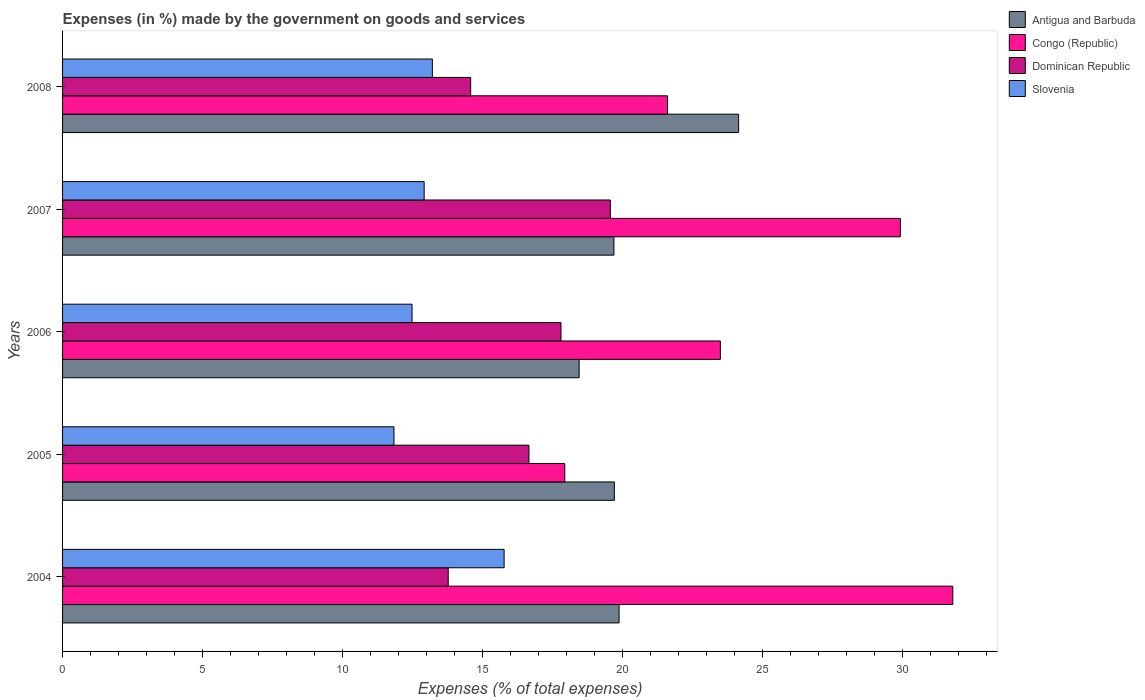How many different coloured bars are there?
Keep it short and to the point. 4. How many bars are there on the 2nd tick from the bottom?
Provide a short and direct response. 4. In how many cases, is the number of bars for a given year not equal to the number of legend labels?
Make the answer very short. 0. What is the percentage of expenses made by the government on goods and services in Antigua and Barbuda in 2004?
Your answer should be compact. 19.87. Across all years, what is the maximum percentage of expenses made by the government on goods and services in Dominican Republic?
Offer a very short reply. 19.56. Across all years, what is the minimum percentage of expenses made by the government on goods and services in Antigua and Barbuda?
Keep it short and to the point. 18.45. In which year was the percentage of expenses made by the government on goods and services in Dominican Republic maximum?
Your response must be concise. 2007. What is the total percentage of expenses made by the government on goods and services in Slovenia in the graph?
Your answer should be very brief. 66.2. What is the difference between the percentage of expenses made by the government on goods and services in Dominican Republic in 2006 and that in 2008?
Your answer should be compact. 3.23. What is the difference between the percentage of expenses made by the government on goods and services in Congo (Republic) in 2005 and the percentage of expenses made by the government on goods and services in Slovenia in 2007?
Offer a terse response. 5.02. What is the average percentage of expenses made by the government on goods and services in Congo (Republic) per year?
Make the answer very short. 24.95. In the year 2006, what is the difference between the percentage of expenses made by the government on goods and services in Congo (Republic) and percentage of expenses made by the government on goods and services in Antigua and Barbuda?
Your answer should be compact. 5.04. What is the ratio of the percentage of expenses made by the government on goods and services in Slovenia in 2005 to that in 2006?
Your answer should be compact. 0.95. What is the difference between the highest and the second highest percentage of expenses made by the government on goods and services in Dominican Republic?
Make the answer very short. 1.76. What is the difference between the highest and the lowest percentage of expenses made by the government on goods and services in Slovenia?
Your answer should be very brief. 3.93. In how many years, is the percentage of expenses made by the government on goods and services in Congo (Republic) greater than the average percentage of expenses made by the government on goods and services in Congo (Republic) taken over all years?
Keep it short and to the point. 2. What does the 3rd bar from the top in 2007 represents?
Make the answer very short. Congo (Republic). What does the 4th bar from the bottom in 2007 represents?
Offer a terse response. Slovenia. Is it the case that in every year, the sum of the percentage of expenses made by the government on goods and services in Congo (Republic) and percentage of expenses made by the government on goods and services in Slovenia is greater than the percentage of expenses made by the government on goods and services in Antigua and Barbuda?
Ensure brevity in your answer.  Yes. How many bars are there?
Keep it short and to the point. 20. Are all the bars in the graph horizontal?
Your answer should be compact. Yes. How many years are there in the graph?
Give a very brief answer. 5. What is the difference between two consecutive major ticks on the X-axis?
Ensure brevity in your answer.  5. Does the graph contain grids?
Ensure brevity in your answer.  No. Where does the legend appear in the graph?
Give a very brief answer. Top right. How are the legend labels stacked?
Offer a very short reply. Vertical. What is the title of the graph?
Ensure brevity in your answer.  Expenses (in %) made by the government on goods and services. Does "Middle East & North Africa (all income levels)" appear as one of the legend labels in the graph?
Your response must be concise. No. What is the label or title of the X-axis?
Keep it short and to the point. Expenses (% of total expenses). What is the Expenses (% of total expenses) of Antigua and Barbuda in 2004?
Your response must be concise. 19.87. What is the Expenses (% of total expenses) of Congo (Republic) in 2004?
Provide a short and direct response. 31.79. What is the Expenses (% of total expenses) of Dominican Republic in 2004?
Offer a terse response. 13.77. What is the Expenses (% of total expenses) in Slovenia in 2004?
Provide a short and direct response. 15.77. What is the Expenses (% of total expenses) of Antigua and Barbuda in 2005?
Provide a short and direct response. 19.71. What is the Expenses (% of total expenses) of Congo (Republic) in 2005?
Make the answer very short. 17.93. What is the Expenses (% of total expenses) in Dominican Republic in 2005?
Provide a succinct answer. 16.65. What is the Expenses (% of total expenses) in Slovenia in 2005?
Your answer should be very brief. 11.83. What is the Expenses (% of total expenses) of Antigua and Barbuda in 2006?
Ensure brevity in your answer.  18.45. What is the Expenses (% of total expenses) in Congo (Republic) in 2006?
Make the answer very short. 23.49. What is the Expenses (% of total expenses) in Dominican Republic in 2006?
Provide a succinct answer. 17.8. What is the Expenses (% of total expenses) of Slovenia in 2006?
Your answer should be very brief. 12.48. What is the Expenses (% of total expenses) in Antigua and Barbuda in 2007?
Give a very brief answer. 19.69. What is the Expenses (% of total expenses) in Congo (Republic) in 2007?
Ensure brevity in your answer.  29.92. What is the Expenses (% of total expenses) in Dominican Republic in 2007?
Offer a very short reply. 19.56. What is the Expenses (% of total expenses) in Slovenia in 2007?
Your answer should be very brief. 12.91. What is the Expenses (% of total expenses) in Antigua and Barbuda in 2008?
Your response must be concise. 24.14. What is the Expenses (% of total expenses) of Congo (Republic) in 2008?
Give a very brief answer. 21.6. What is the Expenses (% of total expenses) of Dominican Republic in 2008?
Offer a very short reply. 14.57. What is the Expenses (% of total expenses) in Slovenia in 2008?
Provide a short and direct response. 13.21. Across all years, what is the maximum Expenses (% of total expenses) in Antigua and Barbuda?
Keep it short and to the point. 24.14. Across all years, what is the maximum Expenses (% of total expenses) in Congo (Republic)?
Ensure brevity in your answer.  31.79. Across all years, what is the maximum Expenses (% of total expenses) in Dominican Republic?
Offer a very short reply. 19.56. Across all years, what is the maximum Expenses (% of total expenses) in Slovenia?
Your response must be concise. 15.77. Across all years, what is the minimum Expenses (% of total expenses) of Antigua and Barbuda?
Offer a very short reply. 18.45. Across all years, what is the minimum Expenses (% of total expenses) of Congo (Republic)?
Your answer should be very brief. 17.93. Across all years, what is the minimum Expenses (% of total expenses) of Dominican Republic?
Offer a very short reply. 13.77. Across all years, what is the minimum Expenses (% of total expenses) of Slovenia?
Your answer should be compact. 11.83. What is the total Expenses (% of total expenses) of Antigua and Barbuda in the graph?
Offer a terse response. 101.86. What is the total Expenses (% of total expenses) in Congo (Republic) in the graph?
Provide a succinct answer. 124.73. What is the total Expenses (% of total expenses) of Dominican Republic in the graph?
Your answer should be compact. 82.36. What is the total Expenses (% of total expenses) in Slovenia in the graph?
Ensure brevity in your answer.  66.2. What is the difference between the Expenses (% of total expenses) in Antigua and Barbuda in 2004 and that in 2005?
Give a very brief answer. 0.17. What is the difference between the Expenses (% of total expenses) in Congo (Republic) in 2004 and that in 2005?
Your answer should be compact. 13.86. What is the difference between the Expenses (% of total expenses) of Dominican Republic in 2004 and that in 2005?
Keep it short and to the point. -2.88. What is the difference between the Expenses (% of total expenses) in Slovenia in 2004 and that in 2005?
Your answer should be very brief. 3.93. What is the difference between the Expenses (% of total expenses) of Antigua and Barbuda in 2004 and that in 2006?
Keep it short and to the point. 1.43. What is the difference between the Expenses (% of total expenses) in Congo (Republic) in 2004 and that in 2006?
Offer a terse response. 8.3. What is the difference between the Expenses (% of total expenses) in Dominican Republic in 2004 and that in 2006?
Provide a short and direct response. -4.03. What is the difference between the Expenses (% of total expenses) in Slovenia in 2004 and that in 2006?
Give a very brief answer. 3.29. What is the difference between the Expenses (% of total expenses) in Antigua and Barbuda in 2004 and that in 2007?
Ensure brevity in your answer.  0.18. What is the difference between the Expenses (% of total expenses) of Congo (Republic) in 2004 and that in 2007?
Offer a very short reply. 1.87. What is the difference between the Expenses (% of total expenses) of Dominican Republic in 2004 and that in 2007?
Make the answer very short. -5.79. What is the difference between the Expenses (% of total expenses) of Slovenia in 2004 and that in 2007?
Ensure brevity in your answer.  2.86. What is the difference between the Expenses (% of total expenses) of Antigua and Barbuda in 2004 and that in 2008?
Provide a succinct answer. -4.27. What is the difference between the Expenses (% of total expenses) of Congo (Republic) in 2004 and that in 2008?
Keep it short and to the point. 10.19. What is the difference between the Expenses (% of total expenses) of Dominican Republic in 2004 and that in 2008?
Your response must be concise. -0.8. What is the difference between the Expenses (% of total expenses) in Slovenia in 2004 and that in 2008?
Give a very brief answer. 2.56. What is the difference between the Expenses (% of total expenses) of Antigua and Barbuda in 2005 and that in 2006?
Your response must be concise. 1.26. What is the difference between the Expenses (% of total expenses) in Congo (Republic) in 2005 and that in 2006?
Your answer should be compact. -5.56. What is the difference between the Expenses (% of total expenses) in Dominican Republic in 2005 and that in 2006?
Give a very brief answer. -1.14. What is the difference between the Expenses (% of total expenses) of Slovenia in 2005 and that in 2006?
Provide a succinct answer. -0.65. What is the difference between the Expenses (% of total expenses) in Antigua and Barbuda in 2005 and that in 2007?
Offer a very short reply. 0.01. What is the difference between the Expenses (% of total expenses) of Congo (Republic) in 2005 and that in 2007?
Give a very brief answer. -11.98. What is the difference between the Expenses (% of total expenses) in Dominican Republic in 2005 and that in 2007?
Give a very brief answer. -2.91. What is the difference between the Expenses (% of total expenses) of Slovenia in 2005 and that in 2007?
Your answer should be very brief. -1.08. What is the difference between the Expenses (% of total expenses) in Antigua and Barbuda in 2005 and that in 2008?
Offer a terse response. -4.44. What is the difference between the Expenses (% of total expenses) in Congo (Republic) in 2005 and that in 2008?
Provide a succinct answer. -3.67. What is the difference between the Expenses (% of total expenses) in Dominican Republic in 2005 and that in 2008?
Offer a terse response. 2.08. What is the difference between the Expenses (% of total expenses) of Slovenia in 2005 and that in 2008?
Offer a very short reply. -1.37. What is the difference between the Expenses (% of total expenses) of Antigua and Barbuda in 2006 and that in 2007?
Offer a very short reply. -1.24. What is the difference between the Expenses (% of total expenses) of Congo (Republic) in 2006 and that in 2007?
Your answer should be compact. -6.43. What is the difference between the Expenses (% of total expenses) in Dominican Republic in 2006 and that in 2007?
Offer a very short reply. -1.76. What is the difference between the Expenses (% of total expenses) of Slovenia in 2006 and that in 2007?
Your response must be concise. -0.43. What is the difference between the Expenses (% of total expenses) in Antigua and Barbuda in 2006 and that in 2008?
Offer a terse response. -5.69. What is the difference between the Expenses (% of total expenses) in Congo (Republic) in 2006 and that in 2008?
Your answer should be compact. 1.89. What is the difference between the Expenses (% of total expenses) in Dominican Republic in 2006 and that in 2008?
Your answer should be very brief. 3.23. What is the difference between the Expenses (% of total expenses) in Slovenia in 2006 and that in 2008?
Offer a terse response. -0.73. What is the difference between the Expenses (% of total expenses) of Antigua and Barbuda in 2007 and that in 2008?
Offer a terse response. -4.45. What is the difference between the Expenses (% of total expenses) in Congo (Republic) in 2007 and that in 2008?
Give a very brief answer. 8.32. What is the difference between the Expenses (% of total expenses) in Dominican Republic in 2007 and that in 2008?
Provide a succinct answer. 4.99. What is the difference between the Expenses (% of total expenses) in Slovenia in 2007 and that in 2008?
Offer a very short reply. -0.29. What is the difference between the Expenses (% of total expenses) of Antigua and Barbuda in 2004 and the Expenses (% of total expenses) of Congo (Republic) in 2005?
Offer a terse response. 1.94. What is the difference between the Expenses (% of total expenses) of Antigua and Barbuda in 2004 and the Expenses (% of total expenses) of Dominican Republic in 2005?
Your answer should be compact. 3.22. What is the difference between the Expenses (% of total expenses) of Antigua and Barbuda in 2004 and the Expenses (% of total expenses) of Slovenia in 2005?
Your answer should be very brief. 8.04. What is the difference between the Expenses (% of total expenses) of Congo (Republic) in 2004 and the Expenses (% of total expenses) of Dominican Republic in 2005?
Your answer should be very brief. 15.14. What is the difference between the Expenses (% of total expenses) of Congo (Republic) in 2004 and the Expenses (% of total expenses) of Slovenia in 2005?
Your answer should be very brief. 19.96. What is the difference between the Expenses (% of total expenses) in Dominican Republic in 2004 and the Expenses (% of total expenses) in Slovenia in 2005?
Provide a short and direct response. 1.94. What is the difference between the Expenses (% of total expenses) in Antigua and Barbuda in 2004 and the Expenses (% of total expenses) in Congo (Republic) in 2006?
Provide a short and direct response. -3.62. What is the difference between the Expenses (% of total expenses) of Antigua and Barbuda in 2004 and the Expenses (% of total expenses) of Dominican Republic in 2006?
Offer a very short reply. 2.07. What is the difference between the Expenses (% of total expenses) in Antigua and Barbuda in 2004 and the Expenses (% of total expenses) in Slovenia in 2006?
Keep it short and to the point. 7.39. What is the difference between the Expenses (% of total expenses) in Congo (Republic) in 2004 and the Expenses (% of total expenses) in Dominican Republic in 2006?
Make the answer very short. 13.99. What is the difference between the Expenses (% of total expenses) of Congo (Republic) in 2004 and the Expenses (% of total expenses) of Slovenia in 2006?
Make the answer very short. 19.31. What is the difference between the Expenses (% of total expenses) in Dominican Republic in 2004 and the Expenses (% of total expenses) in Slovenia in 2006?
Ensure brevity in your answer.  1.29. What is the difference between the Expenses (% of total expenses) of Antigua and Barbuda in 2004 and the Expenses (% of total expenses) of Congo (Republic) in 2007?
Offer a very short reply. -10.04. What is the difference between the Expenses (% of total expenses) of Antigua and Barbuda in 2004 and the Expenses (% of total expenses) of Dominican Republic in 2007?
Make the answer very short. 0.31. What is the difference between the Expenses (% of total expenses) in Antigua and Barbuda in 2004 and the Expenses (% of total expenses) in Slovenia in 2007?
Keep it short and to the point. 6.96. What is the difference between the Expenses (% of total expenses) in Congo (Republic) in 2004 and the Expenses (% of total expenses) in Dominican Republic in 2007?
Your response must be concise. 12.23. What is the difference between the Expenses (% of total expenses) in Congo (Republic) in 2004 and the Expenses (% of total expenses) in Slovenia in 2007?
Offer a terse response. 18.88. What is the difference between the Expenses (% of total expenses) in Dominican Republic in 2004 and the Expenses (% of total expenses) in Slovenia in 2007?
Provide a short and direct response. 0.86. What is the difference between the Expenses (% of total expenses) of Antigua and Barbuda in 2004 and the Expenses (% of total expenses) of Congo (Republic) in 2008?
Offer a terse response. -1.73. What is the difference between the Expenses (% of total expenses) in Antigua and Barbuda in 2004 and the Expenses (% of total expenses) in Dominican Republic in 2008?
Your answer should be very brief. 5.3. What is the difference between the Expenses (% of total expenses) of Antigua and Barbuda in 2004 and the Expenses (% of total expenses) of Slovenia in 2008?
Keep it short and to the point. 6.67. What is the difference between the Expenses (% of total expenses) of Congo (Republic) in 2004 and the Expenses (% of total expenses) of Dominican Republic in 2008?
Offer a very short reply. 17.22. What is the difference between the Expenses (% of total expenses) of Congo (Republic) in 2004 and the Expenses (% of total expenses) of Slovenia in 2008?
Offer a very short reply. 18.58. What is the difference between the Expenses (% of total expenses) of Dominican Republic in 2004 and the Expenses (% of total expenses) of Slovenia in 2008?
Your response must be concise. 0.57. What is the difference between the Expenses (% of total expenses) of Antigua and Barbuda in 2005 and the Expenses (% of total expenses) of Congo (Republic) in 2006?
Offer a terse response. -3.79. What is the difference between the Expenses (% of total expenses) in Antigua and Barbuda in 2005 and the Expenses (% of total expenses) in Dominican Republic in 2006?
Make the answer very short. 1.91. What is the difference between the Expenses (% of total expenses) of Antigua and Barbuda in 2005 and the Expenses (% of total expenses) of Slovenia in 2006?
Give a very brief answer. 7.23. What is the difference between the Expenses (% of total expenses) in Congo (Republic) in 2005 and the Expenses (% of total expenses) in Dominican Republic in 2006?
Offer a very short reply. 0.13. What is the difference between the Expenses (% of total expenses) in Congo (Republic) in 2005 and the Expenses (% of total expenses) in Slovenia in 2006?
Offer a very short reply. 5.45. What is the difference between the Expenses (% of total expenses) of Dominican Republic in 2005 and the Expenses (% of total expenses) of Slovenia in 2006?
Your response must be concise. 4.17. What is the difference between the Expenses (% of total expenses) of Antigua and Barbuda in 2005 and the Expenses (% of total expenses) of Congo (Republic) in 2007?
Your response must be concise. -10.21. What is the difference between the Expenses (% of total expenses) of Antigua and Barbuda in 2005 and the Expenses (% of total expenses) of Dominican Republic in 2007?
Ensure brevity in your answer.  0.14. What is the difference between the Expenses (% of total expenses) in Antigua and Barbuda in 2005 and the Expenses (% of total expenses) in Slovenia in 2007?
Give a very brief answer. 6.79. What is the difference between the Expenses (% of total expenses) of Congo (Republic) in 2005 and the Expenses (% of total expenses) of Dominican Republic in 2007?
Make the answer very short. -1.63. What is the difference between the Expenses (% of total expenses) in Congo (Republic) in 2005 and the Expenses (% of total expenses) in Slovenia in 2007?
Your response must be concise. 5.02. What is the difference between the Expenses (% of total expenses) of Dominican Republic in 2005 and the Expenses (% of total expenses) of Slovenia in 2007?
Your answer should be compact. 3.74. What is the difference between the Expenses (% of total expenses) in Antigua and Barbuda in 2005 and the Expenses (% of total expenses) in Congo (Republic) in 2008?
Your answer should be very brief. -1.9. What is the difference between the Expenses (% of total expenses) in Antigua and Barbuda in 2005 and the Expenses (% of total expenses) in Dominican Republic in 2008?
Your answer should be compact. 5.13. What is the difference between the Expenses (% of total expenses) in Antigua and Barbuda in 2005 and the Expenses (% of total expenses) in Slovenia in 2008?
Offer a terse response. 6.5. What is the difference between the Expenses (% of total expenses) of Congo (Republic) in 2005 and the Expenses (% of total expenses) of Dominican Republic in 2008?
Offer a terse response. 3.36. What is the difference between the Expenses (% of total expenses) of Congo (Republic) in 2005 and the Expenses (% of total expenses) of Slovenia in 2008?
Provide a succinct answer. 4.73. What is the difference between the Expenses (% of total expenses) in Dominican Republic in 2005 and the Expenses (% of total expenses) in Slovenia in 2008?
Provide a short and direct response. 3.45. What is the difference between the Expenses (% of total expenses) of Antigua and Barbuda in 2006 and the Expenses (% of total expenses) of Congo (Republic) in 2007?
Ensure brevity in your answer.  -11.47. What is the difference between the Expenses (% of total expenses) of Antigua and Barbuda in 2006 and the Expenses (% of total expenses) of Dominican Republic in 2007?
Make the answer very short. -1.11. What is the difference between the Expenses (% of total expenses) of Antigua and Barbuda in 2006 and the Expenses (% of total expenses) of Slovenia in 2007?
Provide a short and direct response. 5.53. What is the difference between the Expenses (% of total expenses) of Congo (Republic) in 2006 and the Expenses (% of total expenses) of Dominican Republic in 2007?
Provide a succinct answer. 3.93. What is the difference between the Expenses (% of total expenses) in Congo (Republic) in 2006 and the Expenses (% of total expenses) in Slovenia in 2007?
Provide a short and direct response. 10.58. What is the difference between the Expenses (% of total expenses) in Dominican Republic in 2006 and the Expenses (% of total expenses) in Slovenia in 2007?
Your response must be concise. 4.89. What is the difference between the Expenses (% of total expenses) in Antigua and Barbuda in 2006 and the Expenses (% of total expenses) in Congo (Republic) in 2008?
Give a very brief answer. -3.15. What is the difference between the Expenses (% of total expenses) of Antigua and Barbuda in 2006 and the Expenses (% of total expenses) of Dominican Republic in 2008?
Keep it short and to the point. 3.87. What is the difference between the Expenses (% of total expenses) in Antigua and Barbuda in 2006 and the Expenses (% of total expenses) in Slovenia in 2008?
Provide a short and direct response. 5.24. What is the difference between the Expenses (% of total expenses) of Congo (Republic) in 2006 and the Expenses (% of total expenses) of Dominican Republic in 2008?
Ensure brevity in your answer.  8.92. What is the difference between the Expenses (% of total expenses) of Congo (Republic) in 2006 and the Expenses (% of total expenses) of Slovenia in 2008?
Provide a succinct answer. 10.29. What is the difference between the Expenses (% of total expenses) in Dominican Republic in 2006 and the Expenses (% of total expenses) in Slovenia in 2008?
Ensure brevity in your answer.  4.59. What is the difference between the Expenses (% of total expenses) of Antigua and Barbuda in 2007 and the Expenses (% of total expenses) of Congo (Republic) in 2008?
Ensure brevity in your answer.  -1.91. What is the difference between the Expenses (% of total expenses) of Antigua and Barbuda in 2007 and the Expenses (% of total expenses) of Dominican Republic in 2008?
Offer a very short reply. 5.12. What is the difference between the Expenses (% of total expenses) of Antigua and Barbuda in 2007 and the Expenses (% of total expenses) of Slovenia in 2008?
Give a very brief answer. 6.49. What is the difference between the Expenses (% of total expenses) in Congo (Republic) in 2007 and the Expenses (% of total expenses) in Dominican Republic in 2008?
Your answer should be compact. 15.34. What is the difference between the Expenses (% of total expenses) in Congo (Republic) in 2007 and the Expenses (% of total expenses) in Slovenia in 2008?
Ensure brevity in your answer.  16.71. What is the difference between the Expenses (% of total expenses) of Dominican Republic in 2007 and the Expenses (% of total expenses) of Slovenia in 2008?
Offer a very short reply. 6.36. What is the average Expenses (% of total expenses) of Antigua and Barbuda per year?
Your response must be concise. 20.37. What is the average Expenses (% of total expenses) in Congo (Republic) per year?
Offer a terse response. 24.95. What is the average Expenses (% of total expenses) in Dominican Republic per year?
Offer a terse response. 16.47. What is the average Expenses (% of total expenses) in Slovenia per year?
Your answer should be compact. 13.24. In the year 2004, what is the difference between the Expenses (% of total expenses) of Antigua and Barbuda and Expenses (% of total expenses) of Congo (Republic)?
Keep it short and to the point. -11.92. In the year 2004, what is the difference between the Expenses (% of total expenses) of Antigua and Barbuda and Expenses (% of total expenses) of Dominican Republic?
Give a very brief answer. 6.1. In the year 2004, what is the difference between the Expenses (% of total expenses) of Antigua and Barbuda and Expenses (% of total expenses) of Slovenia?
Your answer should be compact. 4.11. In the year 2004, what is the difference between the Expenses (% of total expenses) of Congo (Republic) and Expenses (% of total expenses) of Dominican Republic?
Provide a succinct answer. 18.02. In the year 2004, what is the difference between the Expenses (% of total expenses) in Congo (Republic) and Expenses (% of total expenses) in Slovenia?
Your response must be concise. 16.02. In the year 2004, what is the difference between the Expenses (% of total expenses) in Dominican Republic and Expenses (% of total expenses) in Slovenia?
Your answer should be compact. -2. In the year 2005, what is the difference between the Expenses (% of total expenses) of Antigua and Barbuda and Expenses (% of total expenses) of Congo (Republic)?
Make the answer very short. 1.77. In the year 2005, what is the difference between the Expenses (% of total expenses) of Antigua and Barbuda and Expenses (% of total expenses) of Dominican Republic?
Offer a terse response. 3.05. In the year 2005, what is the difference between the Expenses (% of total expenses) of Antigua and Barbuda and Expenses (% of total expenses) of Slovenia?
Keep it short and to the point. 7.87. In the year 2005, what is the difference between the Expenses (% of total expenses) in Congo (Republic) and Expenses (% of total expenses) in Dominican Republic?
Provide a succinct answer. 1.28. In the year 2005, what is the difference between the Expenses (% of total expenses) in Congo (Republic) and Expenses (% of total expenses) in Slovenia?
Your answer should be compact. 6.1. In the year 2005, what is the difference between the Expenses (% of total expenses) of Dominican Republic and Expenses (% of total expenses) of Slovenia?
Make the answer very short. 4.82. In the year 2006, what is the difference between the Expenses (% of total expenses) in Antigua and Barbuda and Expenses (% of total expenses) in Congo (Republic)?
Provide a succinct answer. -5.04. In the year 2006, what is the difference between the Expenses (% of total expenses) of Antigua and Barbuda and Expenses (% of total expenses) of Dominican Republic?
Make the answer very short. 0.65. In the year 2006, what is the difference between the Expenses (% of total expenses) in Antigua and Barbuda and Expenses (% of total expenses) in Slovenia?
Keep it short and to the point. 5.97. In the year 2006, what is the difference between the Expenses (% of total expenses) in Congo (Republic) and Expenses (% of total expenses) in Dominican Republic?
Provide a short and direct response. 5.69. In the year 2006, what is the difference between the Expenses (% of total expenses) in Congo (Republic) and Expenses (% of total expenses) in Slovenia?
Keep it short and to the point. 11.01. In the year 2006, what is the difference between the Expenses (% of total expenses) of Dominican Republic and Expenses (% of total expenses) of Slovenia?
Make the answer very short. 5.32. In the year 2007, what is the difference between the Expenses (% of total expenses) in Antigua and Barbuda and Expenses (% of total expenses) in Congo (Republic)?
Keep it short and to the point. -10.23. In the year 2007, what is the difference between the Expenses (% of total expenses) in Antigua and Barbuda and Expenses (% of total expenses) in Dominican Republic?
Give a very brief answer. 0.13. In the year 2007, what is the difference between the Expenses (% of total expenses) in Antigua and Barbuda and Expenses (% of total expenses) in Slovenia?
Offer a very short reply. 6.78. In the year 2007, what is the difference between the Expenses (% of total expenses) of Congo (Republic) and Expenses (% of total expenses) of Dominican Republic?
Your response must be concise. 10.36. In the year 2007, what is the difference between the Expenses (% of total expenses) of Congo (Republic) and Expenses (% of total expenses) of Slovenia?
Your answer should be compact. 17.01. In the year 2007, what is the difference between the Expenses (% of total expenses) of Dominican Republic and Expenses (% of total expenses) of Slovenia?
Give a very brief answer. 6.65. In the year 2008, what is the difference between the Expenses (% of total expenses) of Antigua and Barbuda and Expenses (% of total expenses) of Congo (Republic)?
Ensure brevity in your answer.  2.54. In the year 2008, what is the difference between the Expenses (% of total expenses) of Antigua and Barbuda and Expenses (% of total expenses) of Dominican Republic?
Make the answer very short. 9.57. In the year 2008, what is the difference between the Expenses (% of total expenses) of Antigua and Barbuda and Expenses (% of total expenses) of Slovenia?
Offer a terse response. 10.94. In the year 2008, what is the difference between the Expenses (% of total expenses) of Congo (Republic) and Expenses (% of total expenses) of Dominican Republic?
Make the answer very short. 7.03. In the year 2008, what is the difference between the Expenses (% of total expenses) of Congo (Republic) and Expenses (% of total expenses) of Slovenia?
Provide a succinct answer. 8.4. In the year 2008, what is the difference between the Expenses (% of total expenses) of Dominican Republic and Expenses (% of total expenses) of Slovenia?
Provide a short and direct response. 1.37. What is the ratio of the Expenses (% of total expenses) in Antigua and Barbuda in 2004 to that in 2005?
Offer a terse response. 1.01. What is the ratio of the Expenses (% of total expenses) of Congo (Republic) in 2004 to that in 2005?
Offer a very short reply. 1.77. What is the ratio of the Expenses (% of total expenses) of Dominican Republic in 2004 to that in 2005?
Ensure brevity in your answer.  0.83. What is the ratio of the Expenses (% of total expenses) of Slovenia in 2004 to that in 2005?
Your answer should be very brief. 1.33. What is the ratio of the Expenses (% of total expenses) in Antigua and Barbuda in 2004 to that in 2006?
Your response must be concise. 1.08. What is the ratio of the Expenses (% of total expenses) of Congo (Republic) in 2004 to that in 2006?
Offer a terse response. 1.35. What is the ratio of the Expenses (% of total expenses) of Dominican Republic in 2004 to that in 2006?
Provide a succinct answer. 0.77. What is the ratio of the Expenses (% of total expenses) in Slovenia in 2004 to that in 2006?
Your answer should be compact. 1.26. What is the ratio of the Expenses (% of total expenses) in Antigua and Barbuda in 2004 to that in 2007?
Offer a very short reply. 1.01. What is the ratio of the Expenses (% of total expenses) of Congo (Republic) in 2004 to that in 2007?
Offer a terse response. 1.06. What is the ratio of the Expenses (% of total expenses) of Dominican Republic in 2004 to that in 2007?
Ensure brevity in your answer.  0.7. What is the ratio of the Expenses (% of total expenses) in Slovenia in 2004 to that in 2007?
Provide a short and direct response. 1.22. What is the ratio of the Expenses (% of total expenses) in Antigua and Barbuda in 2004 to that in 2008?
Make the answer very short. 0.82. What is the ratio of the Expenses (% of total expenses) of Congo (Republic) in 2004 to that in 2008?
Make the answer very short. 1.47. What is the ratio of the Expenses (% of total expenses) of Dominican Republic in 2004 to that in 2008?
Your answer should be compact. 0.94. What is the ratio of the Expenses (% of total expenses) of Slovenia in 2004 to that in 2008?
Provide a succinct answer. 1.19. What is the ratio of the Expenses (% of total expenses) of Antigua and Barbuda in 2005 to that in 2006?
Your response must be concise. 1.07. What is the ratio of the Expenses (% of total expenses) in Congo (Republic) in 2005 to that in 2006?
Provide a short and direct response. 0.76. What is the ratio of the Expenses (% of total expenses) of Dominican Republic in 2005 to that in 2006?
Your response must be concise. 0.94. What is the ratio of the Expenses (% of total expenses) in Slovenia in 2005 to that in 2006?
Your response must be concise. 0.95. What is the ratio of the Expenses (% of total expenses) of Antigua and Barbuda in 2005 to that in 2007?
Make the answer very short. 1. What is the ratio of the Expenses (% of total expenses) in Congo (Republic) in 2005 to that in 2007?
Offer a very short reply. 0.6. What is the ratio of the Expenses (% of total expenses) in Dominican Republic in 2005 to that in 2007?
Offer a terse response. 0.85. What is the ratio of the Expenses (% of total expenses) of Slovenia in 2005 to that in 2007?
Offer a terse response. 0.92. What is the ratio of the Expenses (% of total expenses) in Antigua and Barbuda in 2005 to that in 2008?
Offer a terse response. 0.82. What is the ratio of the Expenses (% of total expenses) of Congo (Republic) in 2005 to that in 2008?
Your answer should be compact. 0.83. What is the ratio of the Expenses (% of total expenses) in Dominican Republic in 2005 to that in 2008?
Keep it short and to the point. 1.14. What is the ratio of the Expenses (% of total expenses) in Slovenia in 2005 to that in 2008?
Keep it short and to the point. 0.9. What is the ratio of the Expenses (% of total expenses) in Antigua and Barbuda in 2006 to that in 2007?
Provide a succinct answer. 0.94. What is the ratio of the Expenses (% of total expenses) of Congo (Republic) in 2006 to that in 2007?
Offer a terse response. 0.79. What is the ratio of the Expenses (% of total expenses) of Dominican Republic in 2006 to that in 2007?
Provide a short and direct response. 0.91. What is the ratio of the Expenses (% of total expenses) in Slovenia in 2006 to that in 2007?
Your answer should be very brief. 0.97. What is the ratio of the Expenses (% of total expenses) of Antigua and Barbuda in 2006 to that in 2008?
Offer a terse response. 0.76. What is the ratio of the Expenses (% of total expenses) of Congo (Republic) in 2006 to that in 2008?
Provide a succinct answer. 1.09. What is the ratio of the Expenses (% of total expenses) in Dominican Republic in 2006 to that in 2008?
Ensure brevity in your answer.  1.22. What is the ratio of the Expenses (% of total expenses) of Slovenia in 2006 to that in 2008?
Make the answer very short. 0.95. What is the ratio of the Expenses (% of total expenses) of Antigua and Barbuda in 2007 to that in 2008?
Your response must be concise. 0.82. What is the ratio of the Expenses (% of total expenses) in Congo (Republic) in 2007 to that in 2008?
Your response must be concise. 1.39. What is the ratio of the Expenses (% of total expenses) in Dominican Republic in 2007 to that in 2008?
Make the answer very short. 1.34. What is the ratio of the Expenses (% of total expenses) of Slovenia in 2007 to that in 2008?
Provide a succinct answer. 0.98. What is the difference between the highest and the second highest Expenses (% of total expenses) of Antigua and Barbuda?
Offer a very short reply. 4.27. What is the difference between the highest and the second highest Expenses (% of total expenses) in Congo (Republic)?
Give a very brief answer. 1.87. What is the difference between the highest and the second highest Expenses (% of total expenses) in Dominican Republic?
Provide a short and direct response. 1.76. What is the difference between the highest and the second highest Expenses (% of total expenses) of Slovenia?
Offer a terse response. 2.56. What is the difference between the highest and the lowest Expenses (% of total expenses) in Antigua and Barbuda?
Offer a terse response. 5.69. What is the difference between the highest and the lowest Expenses (% of total expenses) of Congo (Republic)?
Offer a terse response. 13.86. What is the difference between the highest and the lowest Expenses (% of total expenses) in Dominican Republic?
Your response must be concise. 5.79. What is the difference between the highest and the lowest Expenses (% of total expenses) of Slovenia?
Your response must be concise. 3.93. 